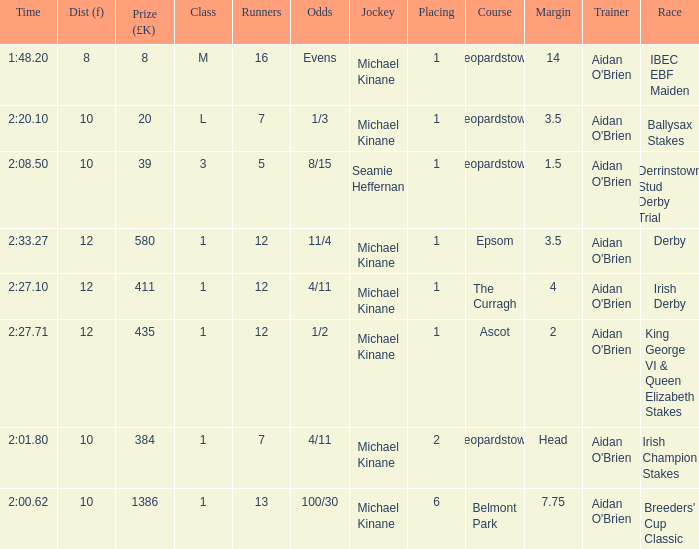Which Race has a Runners of 7 and Odds of 1/3? Ballysax Stakes. 